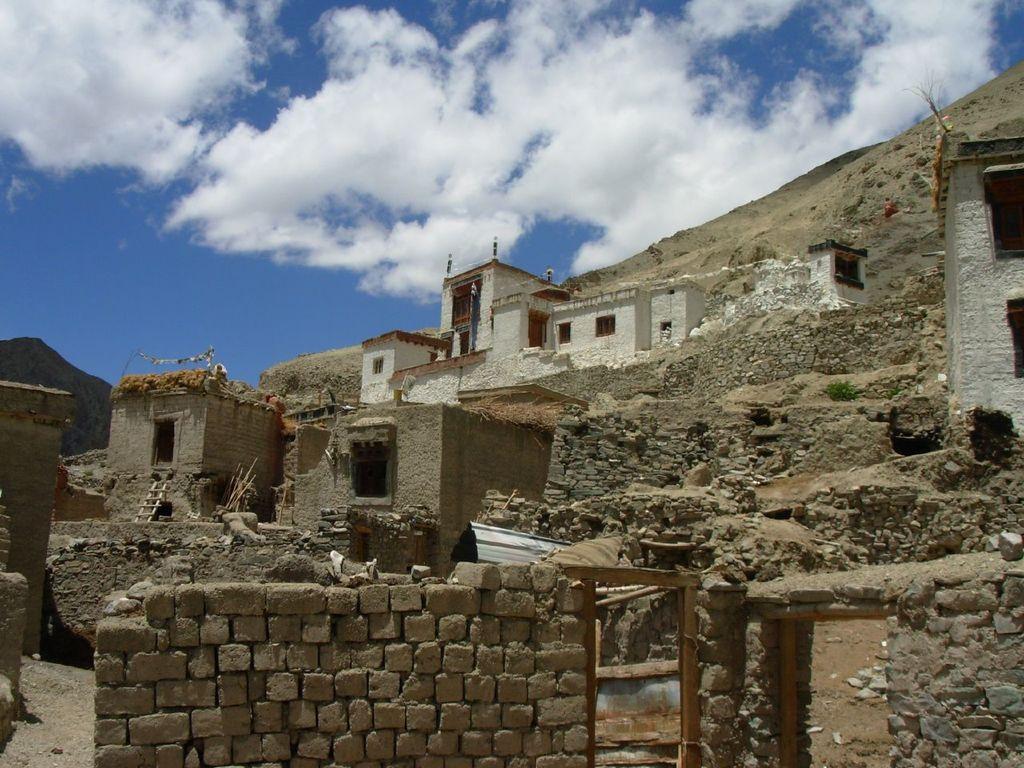Please provide a concise description of this image. In front of the image there is a brick wall. There are buildings. There is a ladder, wooden sticks and a few other objects. At the top of the image there are clouds in the sky. 